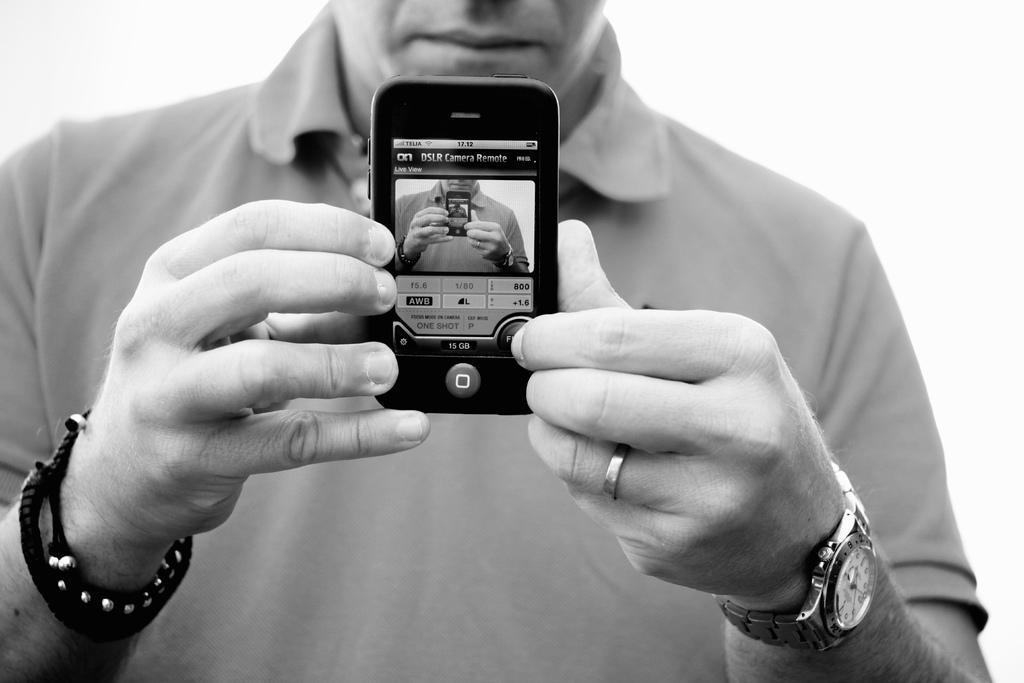Could you give a brief overview of what you see in this image? There is a person holding a mobile. In the background it is white. 